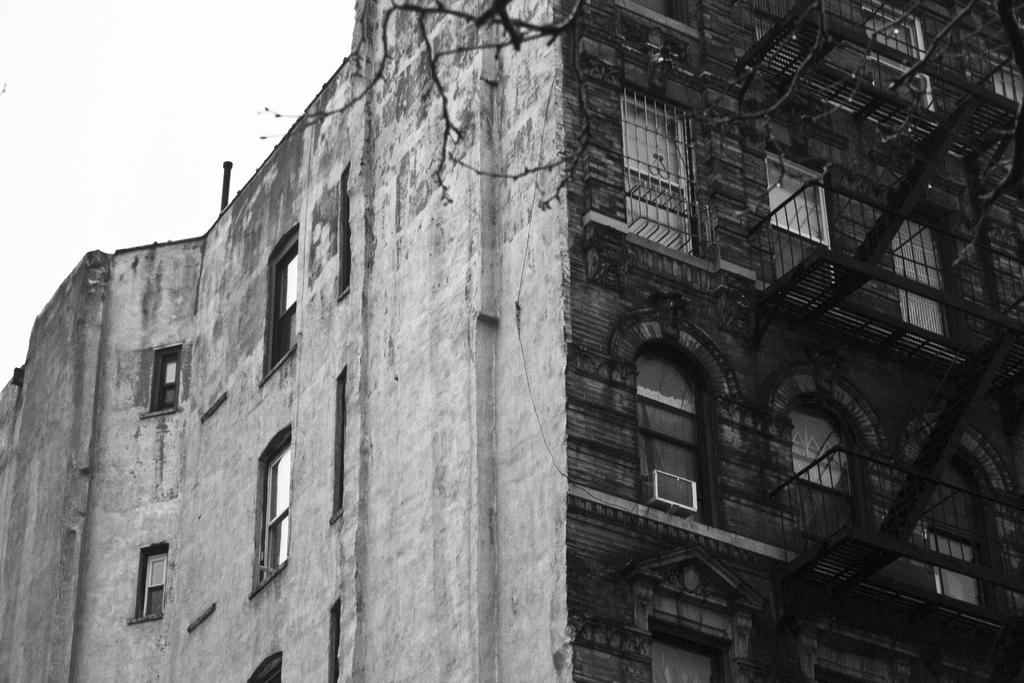What is the color scheme of the image? The image is black and white. What type of structure can be seen in the image? There is a building in the image. What part of the natural environment is visible in the image? The sky is visible in the background of the image. How many cattle can be seen grazing in the foreground of the image? There are no cattle present in the image; it is a black and white image featuring a building and the sky. 